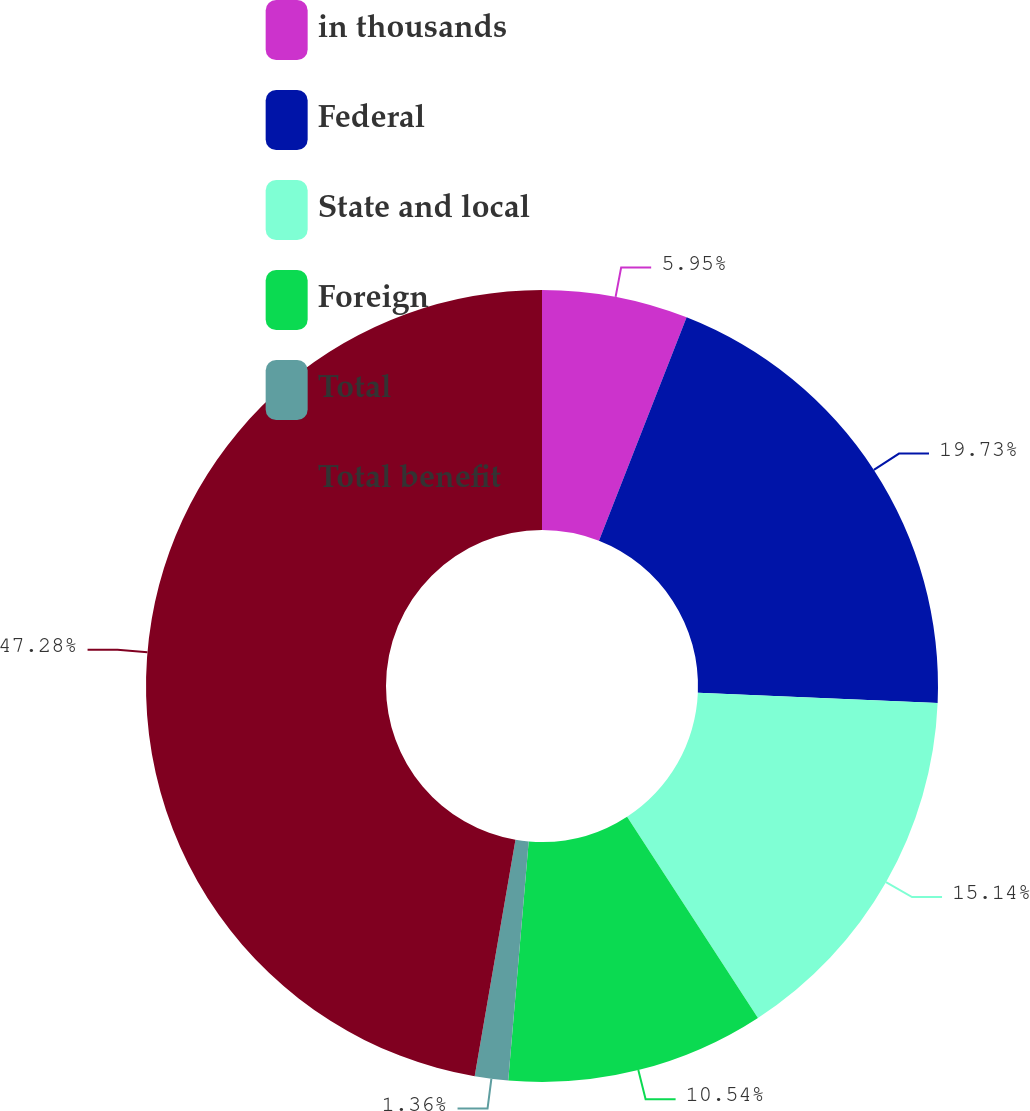Convert chart. <chart><loc_0><loc_0><loc_500><loc_500><pie_chart><fcel>in thousands<fcel>Federal<fcel>State and local<fcel>Foreign<fcel>Total<fcel>Total benefit<nl><fcel>5.95%<fcel>19.73%<fcel>15.14%<fcel>10.54%<fcel>1.36%<fcel>47.28%<nl></chart> 